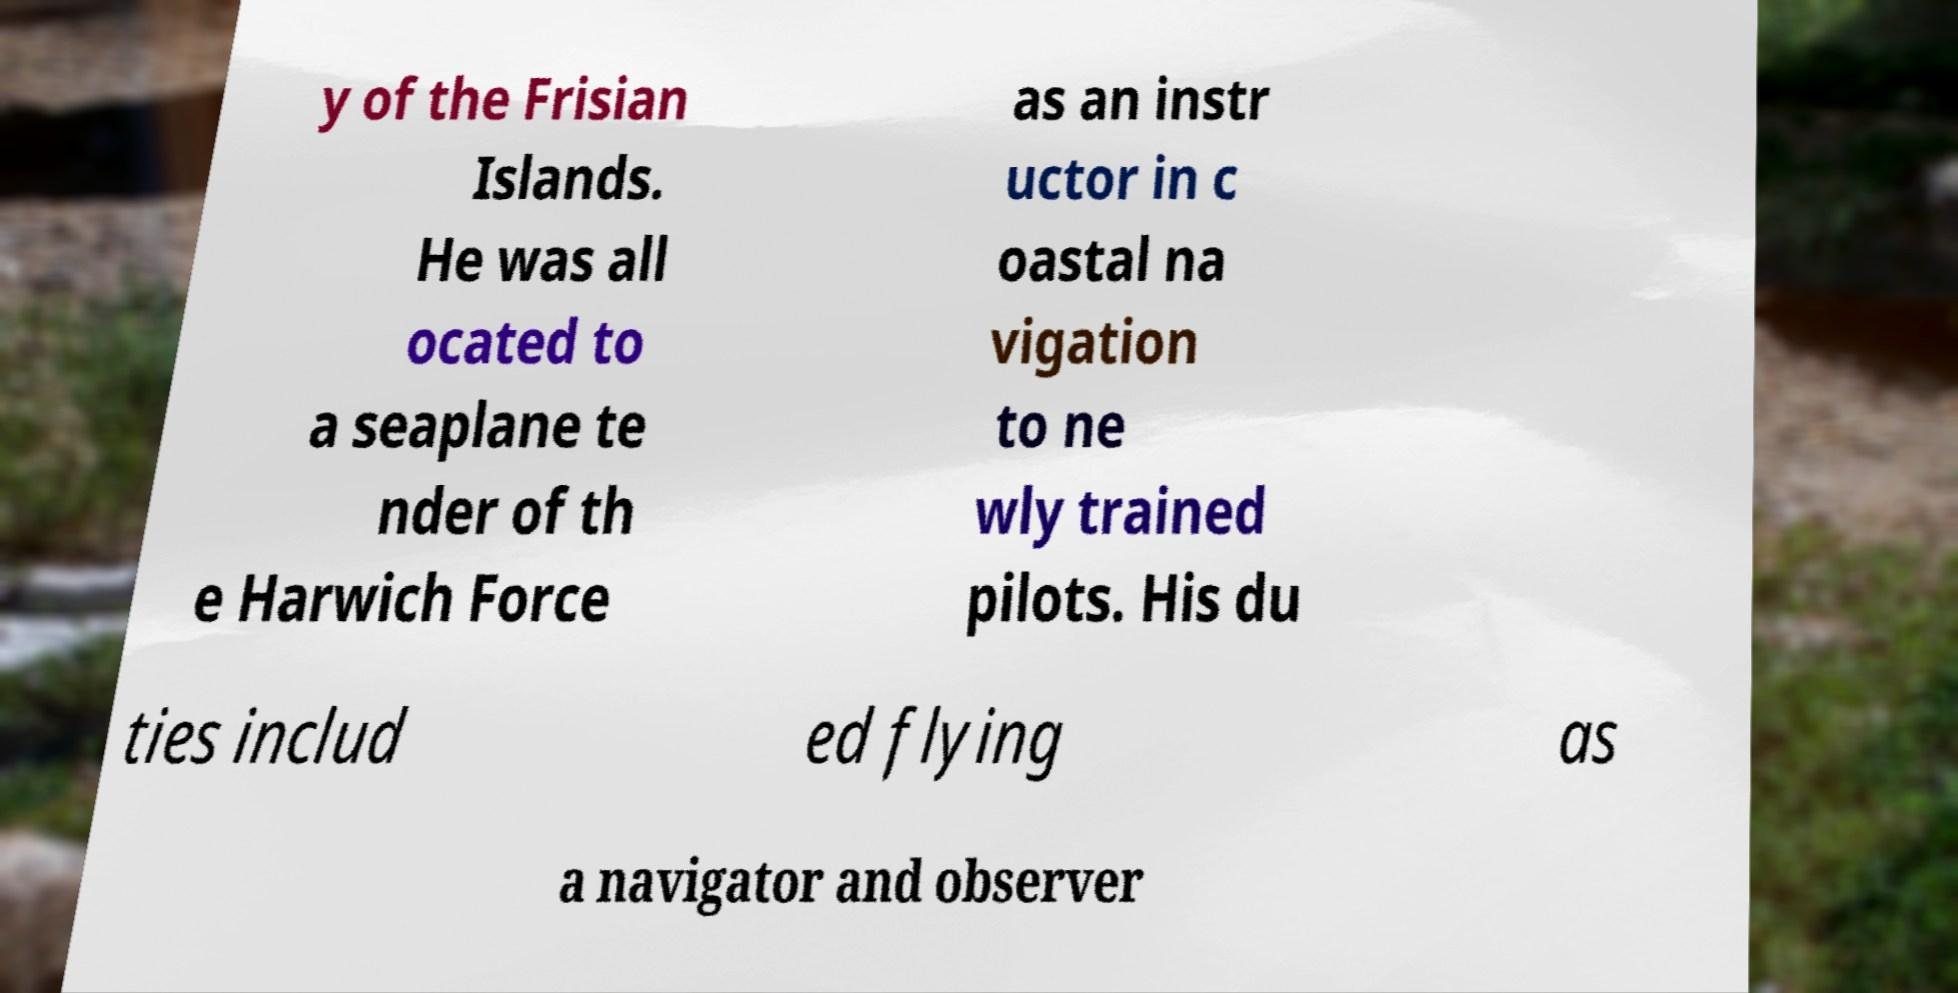For documentation purposes, I need the text within this image transcribed. Could you provide that? y of the Frisian Islands. He was all ocated to a seaplane te nder of th e Harwich Force as an instr uctor in c oastal na vigation to ne wly trained pilots. His du ties includ ed flying as a navigator and observer 